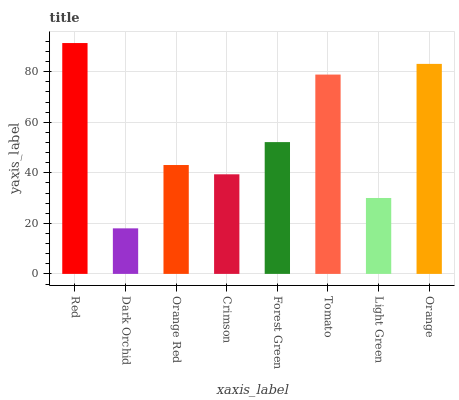Is Orange Red the minimum?
Answer yes or no. No. Is Orange Red the maximum?
Answer yes or no. No. Is Orange Red greater than Dark Orchid?
Answer yes or no. Yes. Is Dark Orchid less than Orange Red?
Answer yes or no. Yes. Is Dark Orchid greater than Orange Red?
Answer yes or no. No. Is Orange Red less than Dark Orchid?
Answer yes or no. No. Is Forest Green the high median?
Answer yes or no. Yes. Is Orange Red the low median?
Answer yes or no. Yes. Is Crimson the high median?
Answer yes or no. No. Is Forest Green the low median?
Answer yes or no. No. 